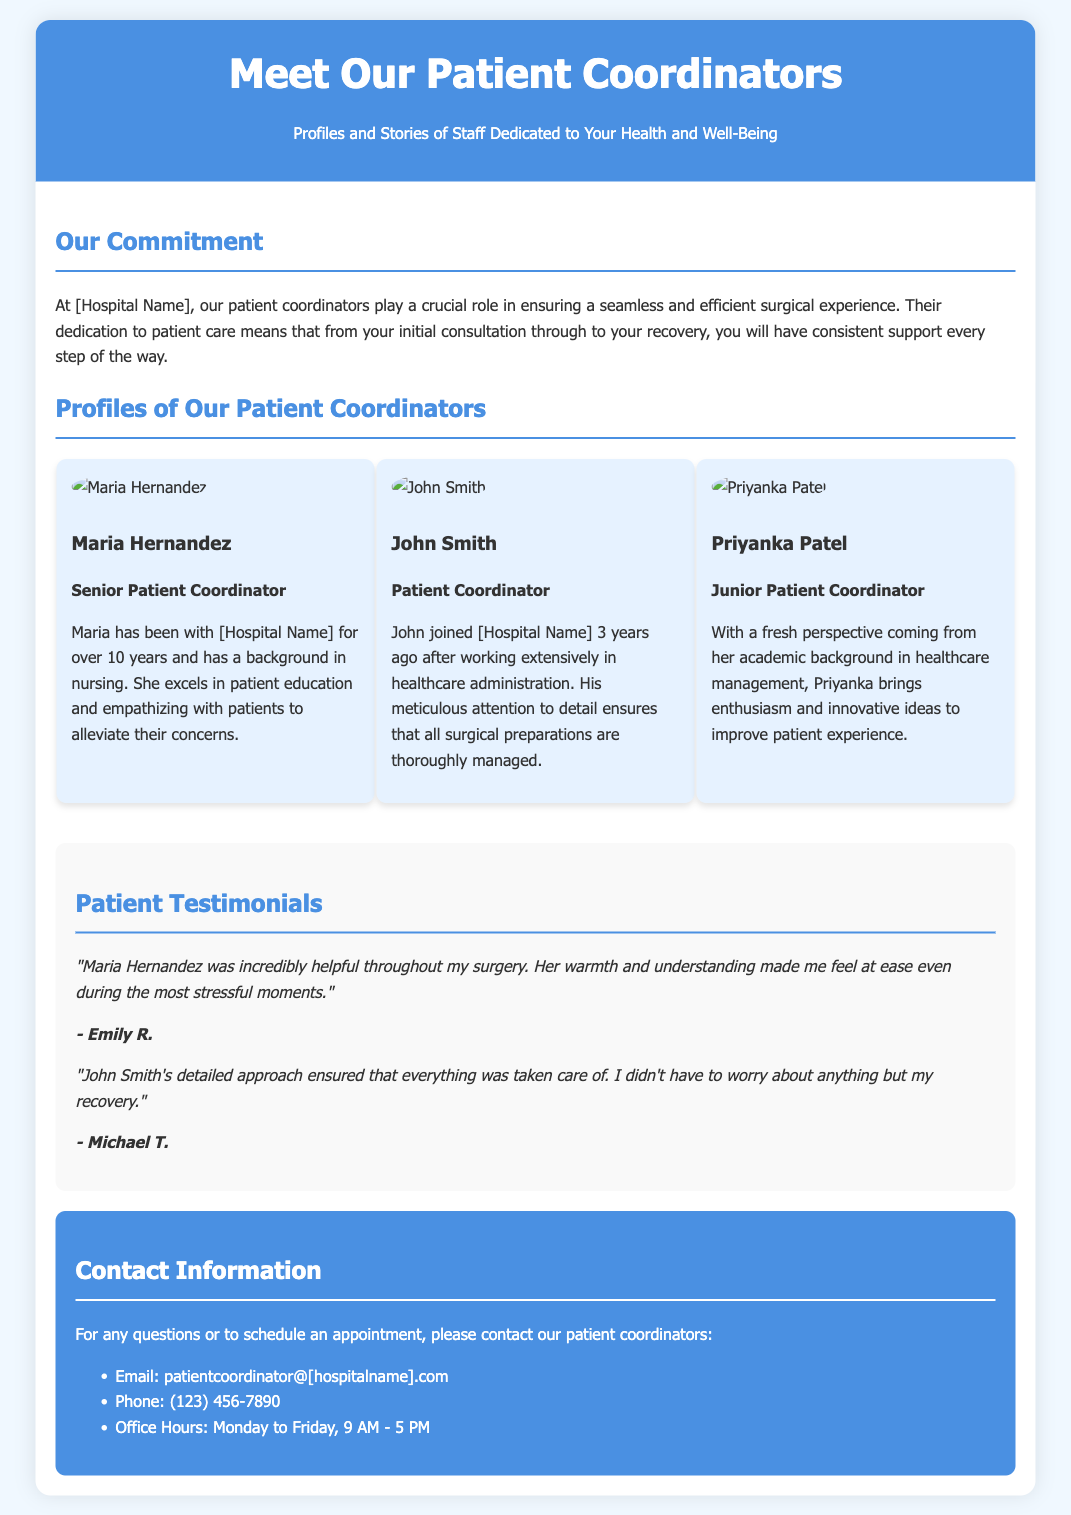What is the title of the document? The title of the document is the main heading, which provides the subject matter of the content.
Answer: Meet Our Patient Coordinators Who is the Senior Patient Coordinator? The title identifies the individual responsible for senior-level coordination, mentioned in the profiles section.
Answer: Maria Hernandez How many years has Maria Hernandez been with the hospital? The years of service for Maria are stated in her profile description.
Answer: over 10 years What is John Smith's background? The background of John Smith is provided in the profile that explains his previous experience before joining the hospital.
Answer: healthcare administration Which patient coordinator emphasizes patient education? This information is derived from the descriptions provided about the coordinators, focusing on specific strengths.
Answer: Maria Hernandez What is Priyanka Patel's role? The role of Priyanka Patel is specified in her profile within the document.
Answer: Junior Patient Coordinator What is the hospital's contact email? The email is stated clearly in the contact information section of the flyer.
Answer: patientcoordinator@[hospitalname].com How can you reach the patient coordinators? This encompasses various methods of communication mentioned in the contact information section of the document.
Answer: Email and Phone What do patient testimonials provide? This refers to the section demonstrating the experiences of past patients with the coordinators.
Answer: Feedback on coordinators' support 